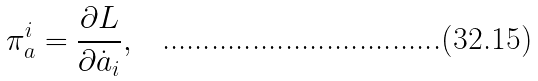Convert formula to latex. <formula><loc_0><loc_0><loc_500><loc_500>\pi _ { a } ^ { i } = \frac { \partial L } { \partial \dot { a } _ { i } } ,</formula> 